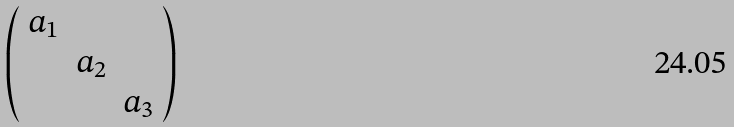<formula> <loc_0><loc_0><loc_500><loc_500>\left ( \begin{array} { c c c } a _ { 1 } & & \\ & a _ { 2 } & \\ & & a _ { 3 } \end{array} \right )</formula> 